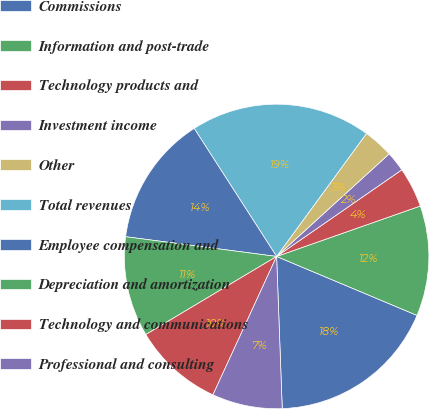Convert chart to OTSL. <chart><loc_0><loc_0><loc_500><loc_500><pie_chart><fcel>Commissions<fcel>Information and post-trade<fcel>Technology products and<fcel>Investment income<fcel>Other<fcel>Total revenues<fcel>Employee compensation and<fcel>Depreciation and amortization<fcel>Technology and communications<fcel>Professional and consulting<nl><fcel>18.09%<fcel>11.7%<fcel>4.26%<fcel>2.13%<fcel>3.19%<fcel>19.15%<fcel>13.83%<fcel>10.64%<fcel>9.57%<fcel>7.45%<nl></chart> 